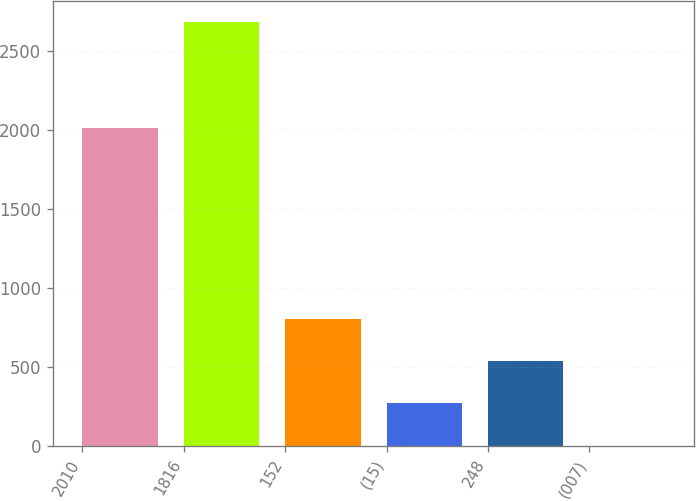<chart> <loc_0><loc_0><loc_500><loc_500><bar_chart><fcel>2010<fcel>1816<fcel>152<fcel>(15)<fcel>248<fcel>(007)<nl><fcel>2010<fcel>2685<fcel>806.11<fcel>269.29<fcel>537.7<fcel>0.88<nl></chart> 